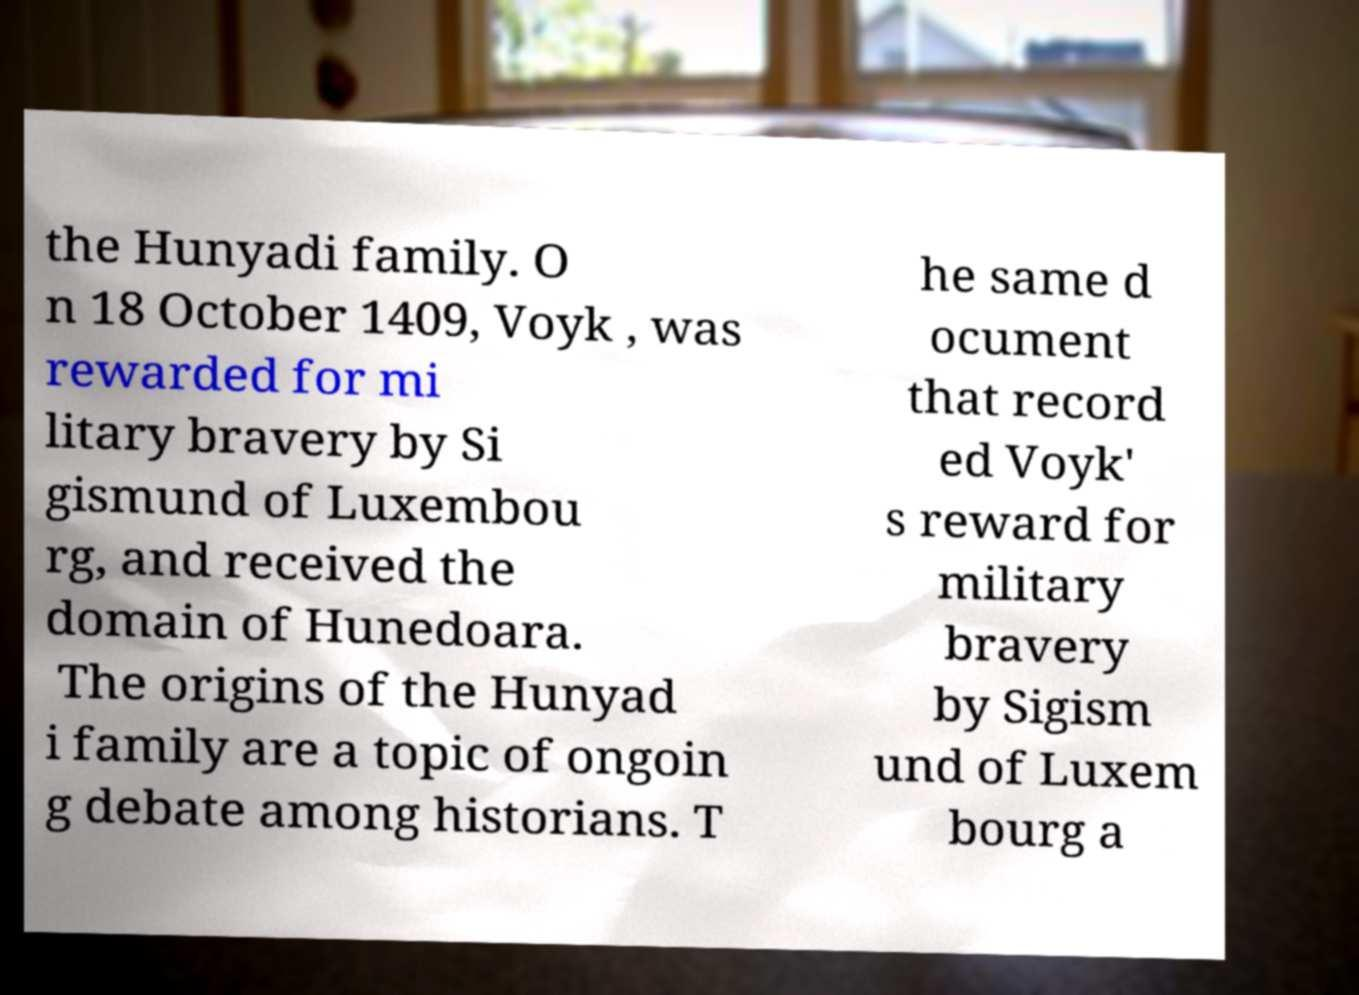Please identify and transcribe the text found in this image. the Hunyadi family. O n 18 October 1409, Voyk , was rewarded for mi litary bravery by Si gismund of Luxembou rg, and received the domain of Hunedoara. The origins of the Hunyad i family are a topic of ongoin g debate among historians. T he same d ocument that record ed Voyk' s reward for military bravery by Sigism und of Luxem bourg a 